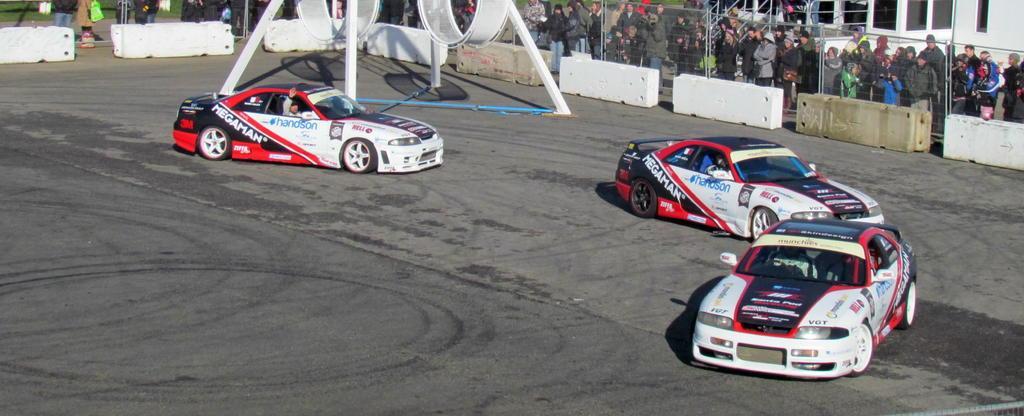Could you give a brief overview of what you see in this image? In this image we can see the cars passing on the road. In the background we can see the barriers and also the fence and behind the fence we can see many people standing and watching. We can also see an object on the road with pillars. 